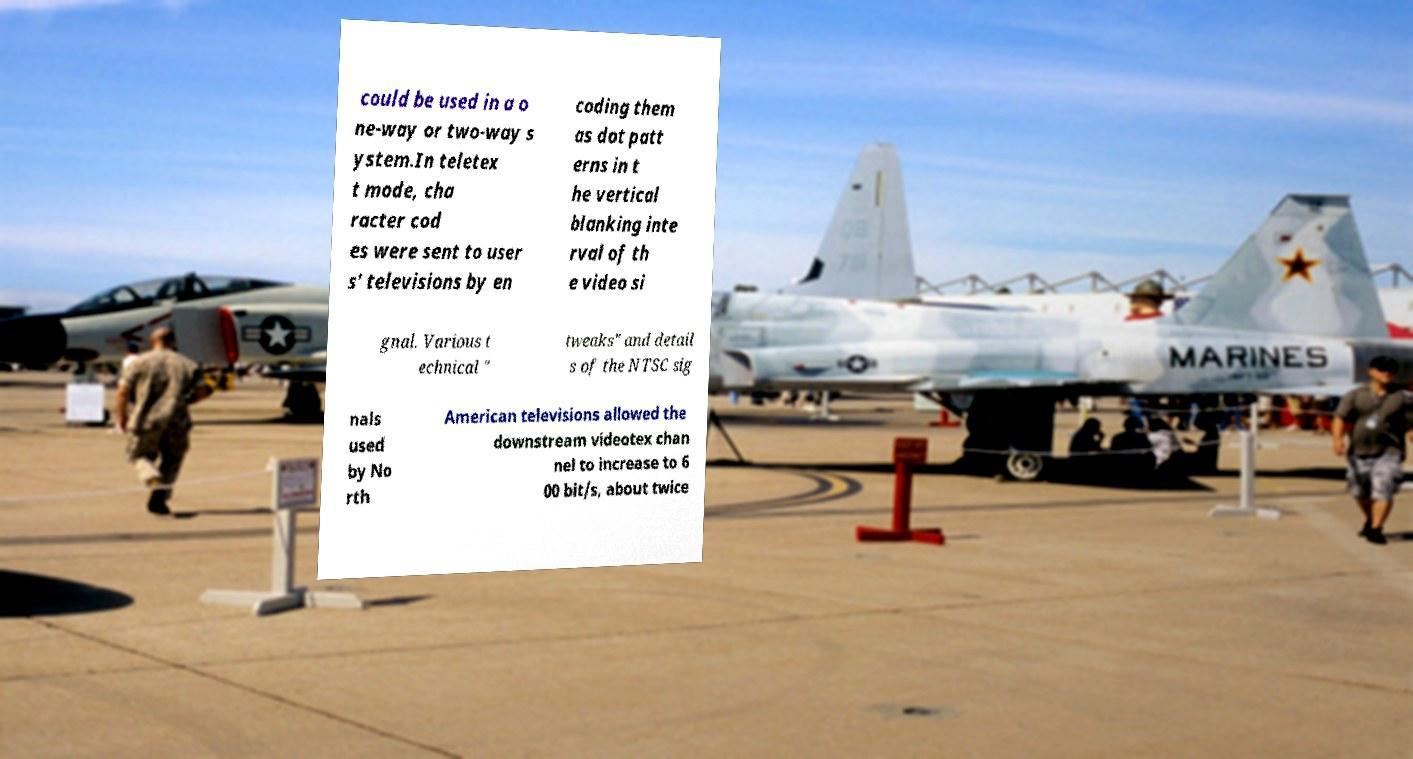Could you extract and type out the text from this image? could be used in a o ne-way or two-way s ystem.In teletex t mode, cha racter cod es were sent to user s' televisions by en coding them as dot patt erns in t he vertical blanking inte rval of th e video si gnal. Various t echnical " tweaks" and detail s of the NTSC sig nals used by No rth American televisions allowed the downstream videotex chan nel to increase to 6 00 bit/s, about twice 